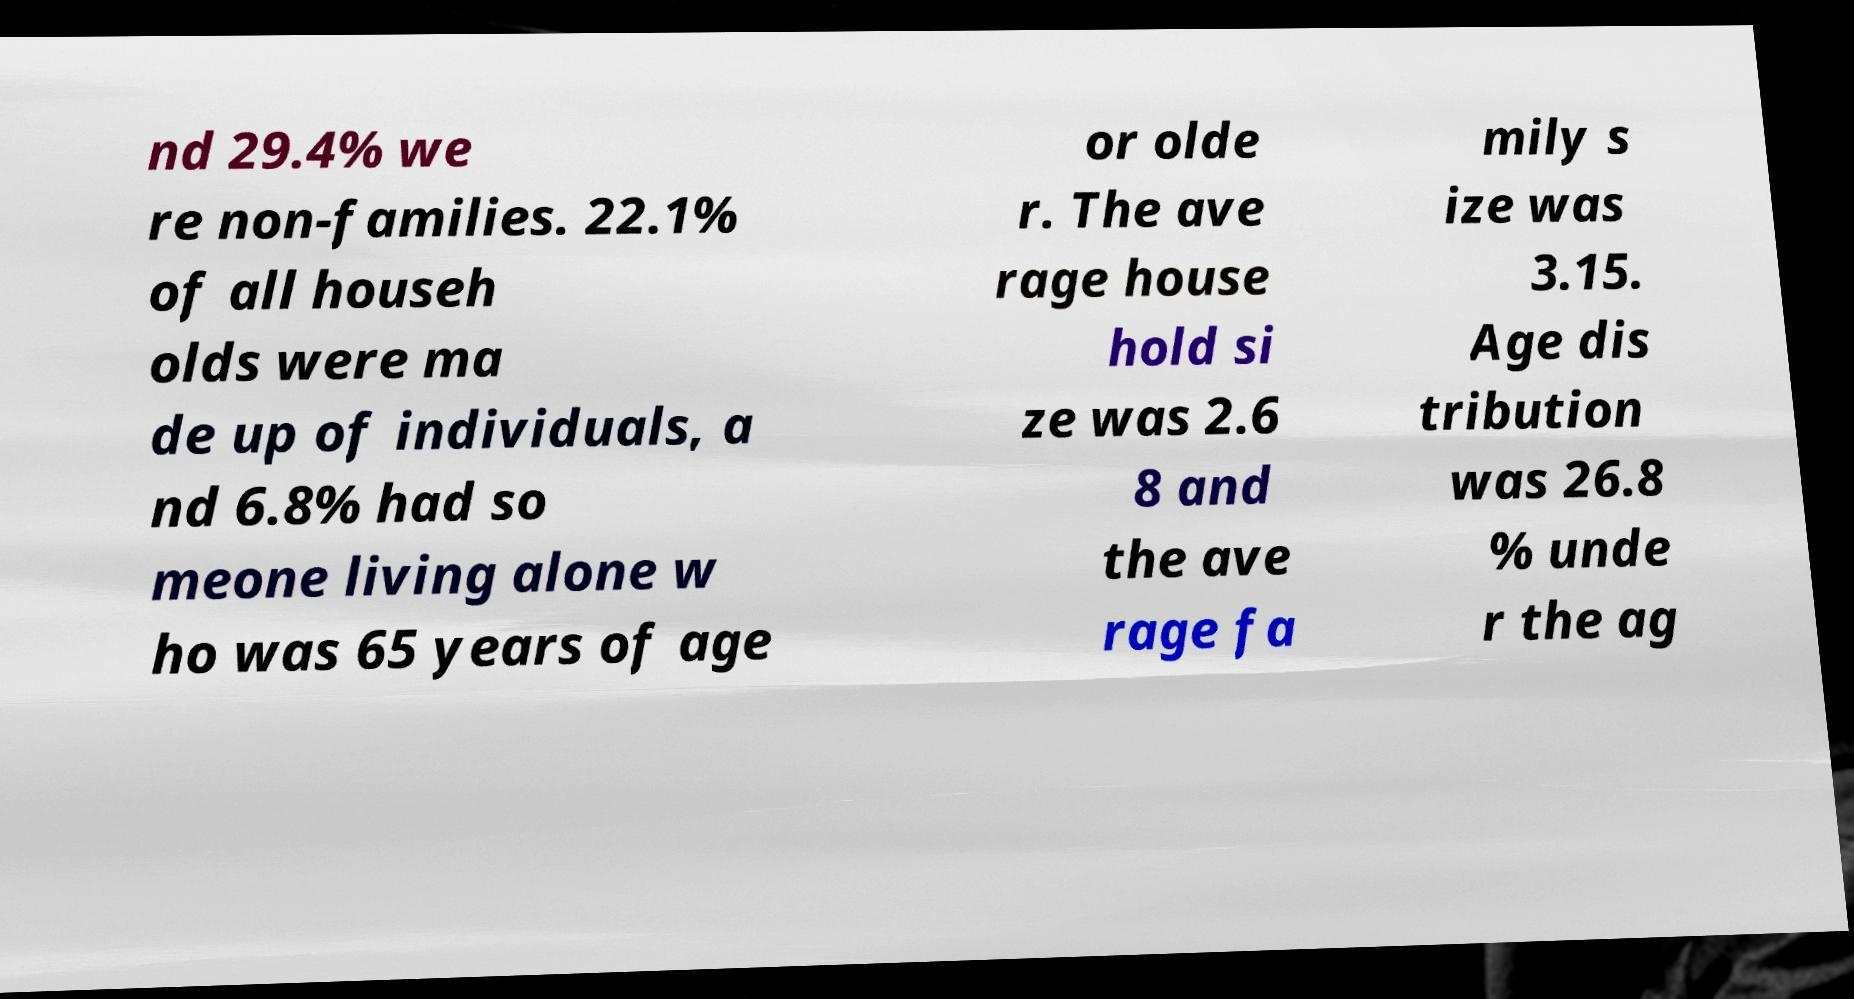Can you accurately transcribe the text from the provided image for me? nd 29.4% we re non-families. 22.1% of all househ olds were ma de up of individuals, a nd 6.8% had so meone living alone w ho was 65 years of age or olde r. The ave rage house hold si ze was 2.6 8 and the ave rage fa mily s ize was 3.15. Age dis tribution was 26.8 % unde r the ag 